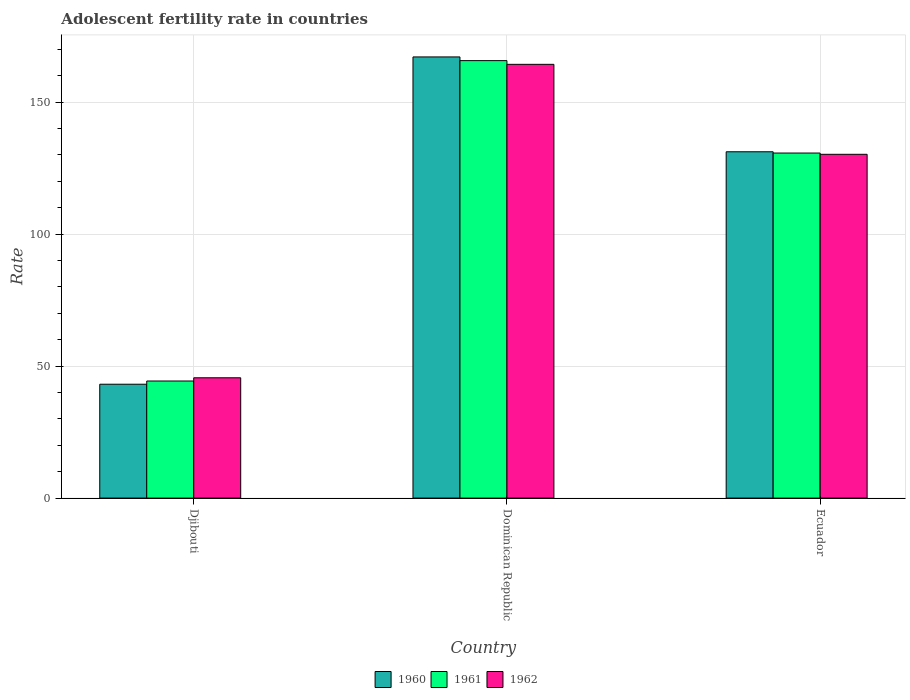Are the number of bars on each tick of the X-axis equal?
Provide a succinct answer. Yes. How many bars are there on the 1st tick from the left?
Your response must be concise. 3. How many bars are there on the 3rd tick from the right?
Your answer should be very brief. 3. What is the label of the 1st group of bars from the left?
Provide a short and direct response. Djibouti. In how many cases, is the number of bars for a given country not equal to the number of legend labels?
Offer a very short reply. 0. What is the adolescent fertility rate in 1962 in Ecuador?
Keep it short and to the point. 130.22. Across all countries, what is the maximum adolescent fertility rate in 1962?
Provide a short and direct response. 164.3. Across all countries, what is the minimum adolescent fertility rate in 1962?
Make the answer very short. 45.57. In which country was the adolescent fertility rate in 1961 maximum?
Keep it short and to the point. Dominican Republic. In which country was the adolescent fertility rate in 1961 minimum?
Provide a short and direct response. Djibouti. What is the total adolescent fertility rate in 1962 in the graph?
Your answer should be very brief. 340.09. What is the difference between the adolescent fertility rate in 1961 in Djibouti and that in Ecuador?
Make the answer very short. -86.35. What is the difference between the adolescent fertility rate in 1961 in Ecuador and the adolescent fertility rate in 1962 in Djibouti?
Keep it short and to the point. 85.13. What is the average adolescent fertility rate in 1960 per country?
Give a very brief answer. 113.8. What is the difference between the adolescent fertility rate of/in 1962 and adolescent fertility rate of/in 1961 in Dominican Republic?
Give a very brief answer. -1.4. What is the ratio of the adolescent fertility rate in 1961 in Djibouti to that in Dominican Republic?
Your answer should be compact. 0.27. Is the adolescent fertility rate in 1962 in Dominican Republic less than that in Ecuador?
Offer a very short reply. No. Is the difference between the adolescent fertility rate in 1962 in Djibouti and Ecuador greater than the difference between the adolescent fertility rate in 1961 in Djibouti and Ecuador?
Offer a very short reply. Yes. What is the difference between the highest and the second highest adolescent fertility rate in 1960?
Ensure brevity in your answer.  -88.05. What is the difference between the highest and the lowest adolescent fertility rate in 1961?
Provide a succinct answer. 121.35. What does the 2nd bar from the right in Djibouti represents?
Keep it short and to the point. 1961. How many bars are there?
Make the answer very short. 9. Are all the bars in the graph horizontal?
Keep it short and to the point. No. How many countries are there in the graph?
Give a very brief answer. 3. Does the graph contain grids?
Your response must be concise. Yes. How many legend labels are there?
Make the answer very short. 3. How are the legend labels stacked?
Offer a very short reply. Horizontal. What is the title of the graph?
Provide a short and direct response. Adolescent fertility rate in countries. Does "1976" appear as one of the legend labels in the graph?
Keep it short and to the point. No. What is the label or title of the Y-axis?
Keep it short and to the point. Rate. What is the Rate in 1960 in Djibouti?
Make the answer very short. 43.13. What is the Rate of 1961 in Djibouti?
Provide a succinct answer. 44.35. What is the Rate in 1962 in Djibouti?
Ensure brevity in your answer.  45.57. What is the Rate of 1960 in Dominican Republic?
Provide a short and direct response. 167.1. What is the Rate of 1961 in Dominican Republic?
Give a very brief answer. 165.7. What is the Rate in 1962 in Dominican Republic?
Your response must be concise. 164.3. What is the Rate in 1960 in Ecuador?
Make the answer very short. 131.18. What is the Rate in 1961 in Ecuador?
Provide a succinct answer. 130.7. What is the Rate of 1962 in Ecuador?
Make the answer very short. 130.22. Across all countries, what is the maximum Rate of 1960?
Provide a succinct answer. 167.1. Across all countries, what is the maximum Rate of 1961?
Offer a terse response. 165.7. Across all countries, what is the maximum Rate in 1962?
Your answer should be compact. 164.3. Across all countries, what is the minimum Rate in 1960?
Keep it short and to the point. 43.13. Across all countries, what is the minimum Rate of 1961?
Keep it short and to the point. 44.35. Across all countries, what is the minimum Rate in 1962?
Provide a short and direct response. 45.57. What is the total Rate in 1960 in the graph?
Keep it short and to the point. 341.41. What is the total Rate of 1961 in the graph?
Your answer should be compact. 340.75. What is the total Rate of 1962 in the graph?
Offer a terse response. 340.08. What is the difference between the Rate in 1960 in Djibouti and that in Dominican Republic?
Offer a very short reply. -123.97. What is the difference between the Rate in 1961 in Djibouti and that in Dominican Republic?
Ensure brevity in your answer.  -121.35. What is the difference between the Rate of 1962 in Djibouti and that in Dominican Republic?
Provide a short and direct response. -118.73. What is the difference between the Rate in 1960 in Djibouti and that in Ecuador?
Make the answer very short. -88.05. What is the difference between the Rate of 1961 in Djibouti and that in Ecuador?
Offer a very short reply. -86.35. What is the difference between the Rate in 1962 in Djibouti and that in Ecuador?
Keep it short and to the point. -84.65. What is the difference between the Rate of 1960 in Dominican Republic and that in Ecuador?
Your answer should be very brief. 35.92. What is the difference between the Rate in 1961 in Dominican Republic and that in Ecuador?
Make the answer very short. 35. What is the difference between the Rate in 1962 in Dominican Republic and that in Ecuador?
Give a very brief answer. 34.08. What is the difference between the Rate of 1960 in Djibouti and the Rate of 1961 in Dominican Republic?
Your response must be concise. -122.57. What is the difference between the Rate of 1960 in Djibouti and the Rate of 1962 in Dominican Republic?
Offer a very short reply. -121.17. What is the difference between the Rate of 1961 in Djibouti and the Rate of 1962 in Dominican Republic?
Provide a succinct answer. -119.95. What is the difference between the Rate in 1960 in Djibouti and the Rate in 1961 in Ecuador?
Your answer should be compact. -87.57. What is the difference between the Rate in 1960 in Djibouti and the Rate in 1962 in Ecuador?
Provide a short and direct response. -87.09. What is the difference between the Rate of 1961 in Djibouti and the Rate of 1962 in Ecuador?
Your answer should be very brief. -85.87. What is the difference between the Rate of 1960 in Dominican Republic and the Rate of 1961 in Ecuador?
Ensure brevity in your answer.  36.4. What is the difference between the Rate of 1960 in Dominican Republic and the Rate of 1962 in Ecuador?
Your response must be concise. 36.88. What is the difference between the Rate in 1961 in Dominican Republic and the Rate in 1962 in Ecuador?
Provide a succinct answer. 35.48. What is the average Rate in 1960 per country?
Your response must be concise. 113.8. What is the average Rate of 1961 per country?
Ensure brevity in your answer.  113.58. What is the average Rate in 1962 per country?
Give a very brief answer. 113.36. What is the difference between the Rate in 1960 and Rate in 1961 in Djibouti?
Provide a short and direct response. -1.22. What is the difference between the Rate of 1960 and Rate of 1962 in Djibouti?
Offer a terse response. -2.44. What is the difference between the Rate in 1961 and Rate in 1962 in Djibouti?
Your response must be concise. -1.22. What is the difference between the Rate in 1960 and Rate in 1961 in Dominican Republic?
Offer a very short reply. 1.4. What is the difference between the Rate in 1960 and Rate in 1962 in Dominican Republic?
Provide a short and direct response. 2.8. What is the difference between the Rate in 1961 and Rate in 1962 in Dominican Republic?
Offer a terse response. 1.4. What is the difference between the Rate in 1960 and Rate in 1961 in Ecuador?
Offer a terse response. 0.48. What is the difference between the Rate of 1960 and Rate of 1962 in Ecuador?
Provide a succinct answer. 0.96. What is the difference between the Rate in 1961 and Rate in 1962 in Ecuador?
Offer a very short reply. 0.48. What is the ratio of the Rate in 1960 in Djibouti to that in Dominican Republic?
Provide a succinct answer. 0.26. What is the ratio of the Rate in 1961 in Djibouti to that in Dominican Republic?
Keep it short and to the point. 0.27. What is the ratio of the Rate of 1962 in Djibouti to that in Dominican Republic?
Your answer should be compact. 0.28. What is the ratio of the Rate in 1960 in Djibouti to that in Ecuador?
Offer a very short reply. 0.33. What is the ratio of the Rate of 1961 in Djibouti to that in Ecuador?
Keep it short and to the point. 0.34. What is the ratio of the Rate in 1962 in Djibouti to that in Ecuador?
Your answer should be compact. 0.35. What is the ratio of the Rate in 1960 in Dominican Republic to that in Ecuador?
Keep it short and to the point. 1.27. What is the ratio of the Rate in 1961 in Dominican Republic to that in Ecuador?
Offer a very short reply. 1.27. What is the ratio of the Rate of 1962 in Dominican Republic to that in Ecuador?
Provide a short and direct response. 1.26. What is the difference between the highest and the second highest Rate of 1960?
Offer a very short reply. 35.92. What is the difference between the highest and the second highest Rate of 1961?
Offer a terse response. 35. What is the difference between the highest and the second highest Rate of 1962?
Give a very brief answer. 34.08. What is the difference between the highest and the lowest Rate in 1960?
Offer a terse response. 123.97. What is the difference between the highest and the lowest Rate of 1961?
Make the answer very short. 121.35. What is the difference between the highest and the lowest Rate in 1962?
Provide a short and direct response. 118.73. 